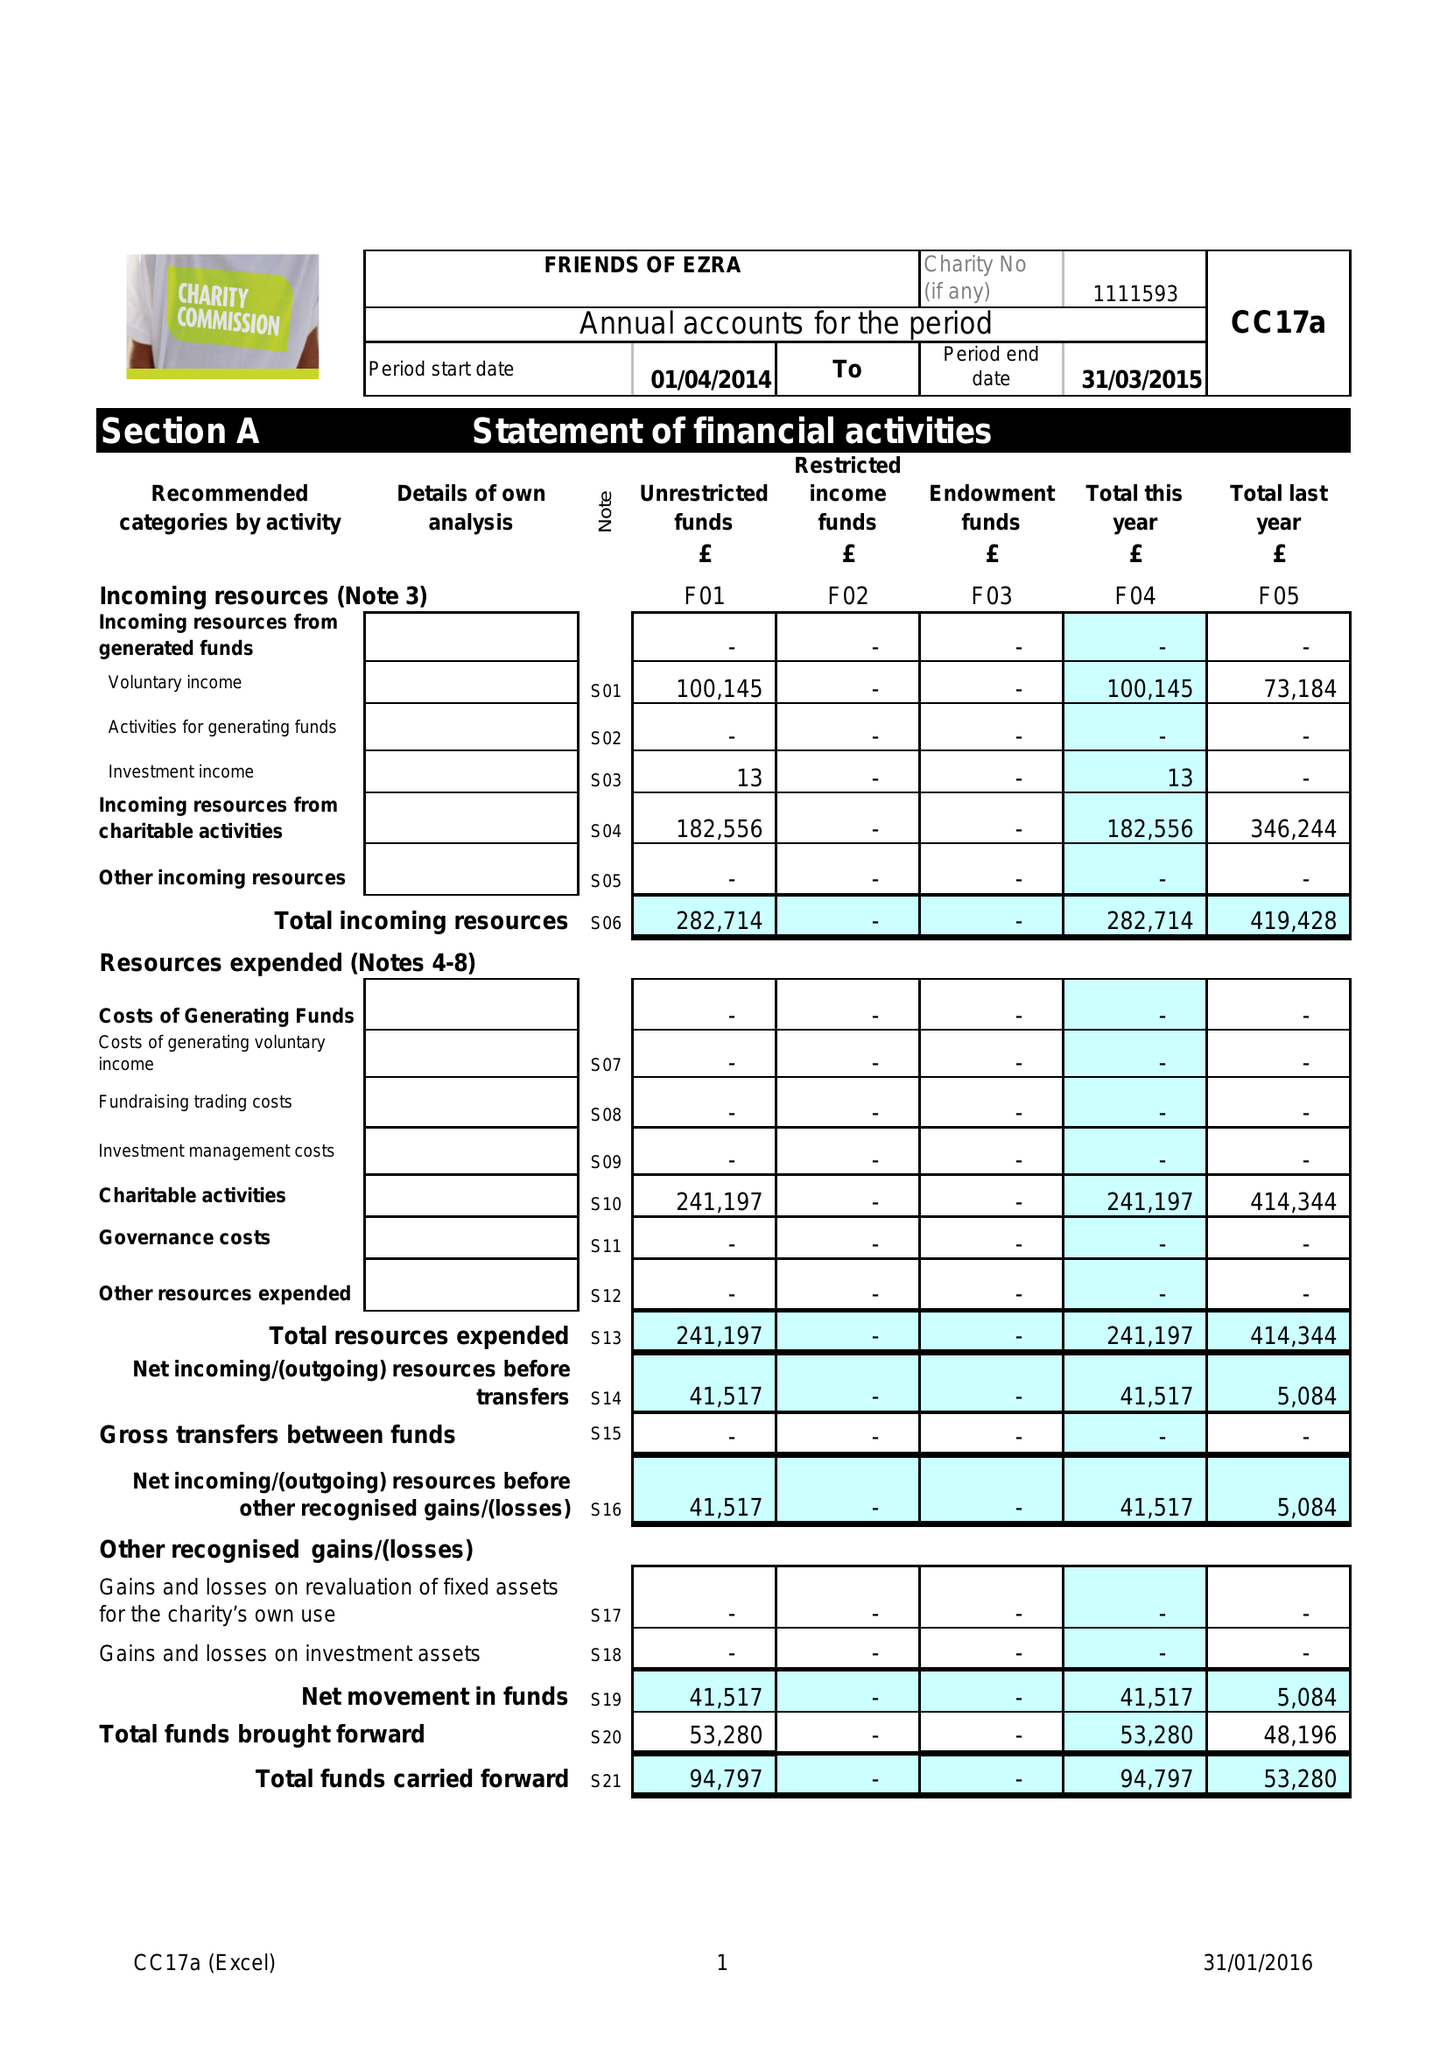What is the value for the charity_number?
Answer the question using a single word or phrase. 1111593 